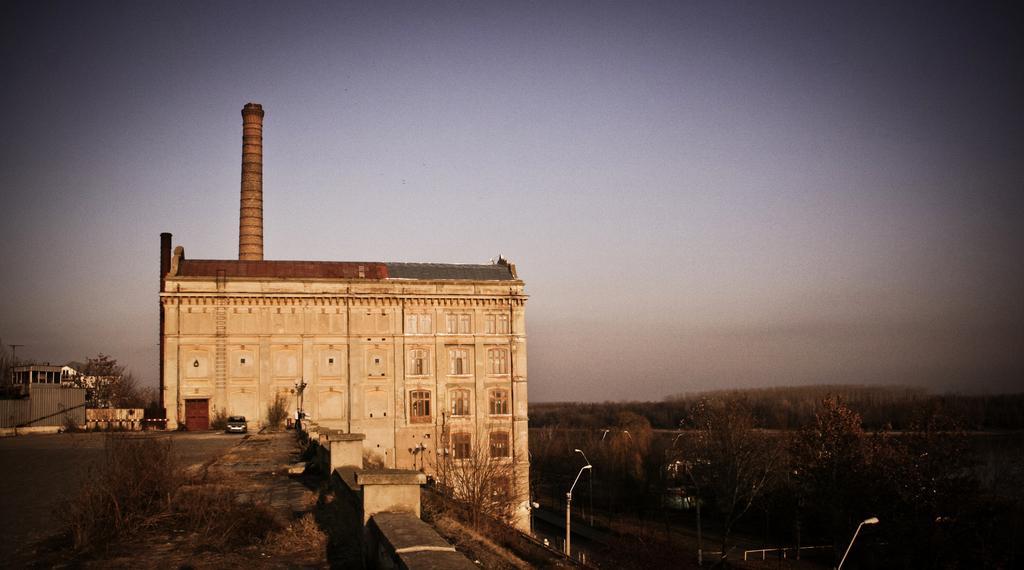Could you give a brief overview of what you see in this image? In this picture we can see buildings with windows, trees, poles, car, road and in the background we can see the sky. 